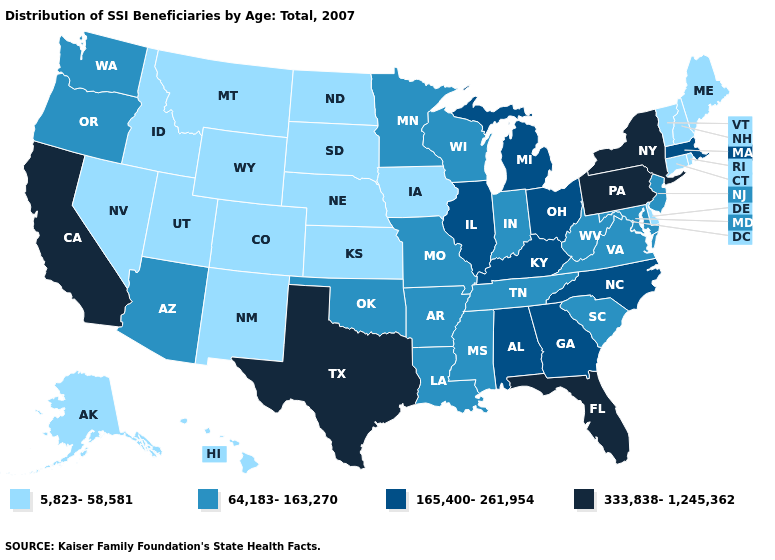What is the highest value in the Northeast ?
Write a very short answer. 333,838-1,245,362. What is the value of South Dakota?
Be succinct. 5,823-58,581. Among the states that border Michigan , which have the lowest value?
Keep it brief. Indiana, Wisconsin. Name the states that have a value in the range 165,400-261,954?
Write a very short answer. Alabama, Georgia, Illinois, Kentucky, Massachusetts, Michigan, North Carolina, Ohio. What is the lowest value in the USA?
Answer briefly. 5,823-58,581. Which states have the lowest value in the USA?
Keep it brief. Alaska, Colorado, Connecticut, Delaware, Hawaii, Idaho, Iowa, Kansas, Maine, Montana, Nebraska, Nevada, New Hampshire, New Mexico, North Dakota, Rhode Island, South Dakota, Utah, Vermont, Wyoming. What is the highest value in the USA?
Answer briefly. 333,838-1,245,362. Name the states that have a value in the range 5,823-58,581?
Short answer required. Alaska, Colorado, Connecticut, Delaware, Hawaii, Idaho, Iowa, Kansas, Maine, Montana, Nebraska, Nevada, New Hampshire, New Mexico, North Dakota, Rhode Island, South Dakota, Utah, Vermont, Wyoming. Among the states that border Nevada , does Utah have the lowest value?
Short answer required. Yes. What is the value of Nebraska?
Concise answer only. 5,823-58,581. Does Hawaii have the highest value in the USA?
Short answer required. No. What is the highest value in the Northeast ?
Short answer required. 333,838-1,245,362. Does the first symbol in the legend represent the smallest category?
Answer briefly. Yes. What is the value of North Dakota?
Give a very brief answer. 5,823-58,581. What is the highest value in the MidWest ?
Short answer required. 165,400-261,954. 